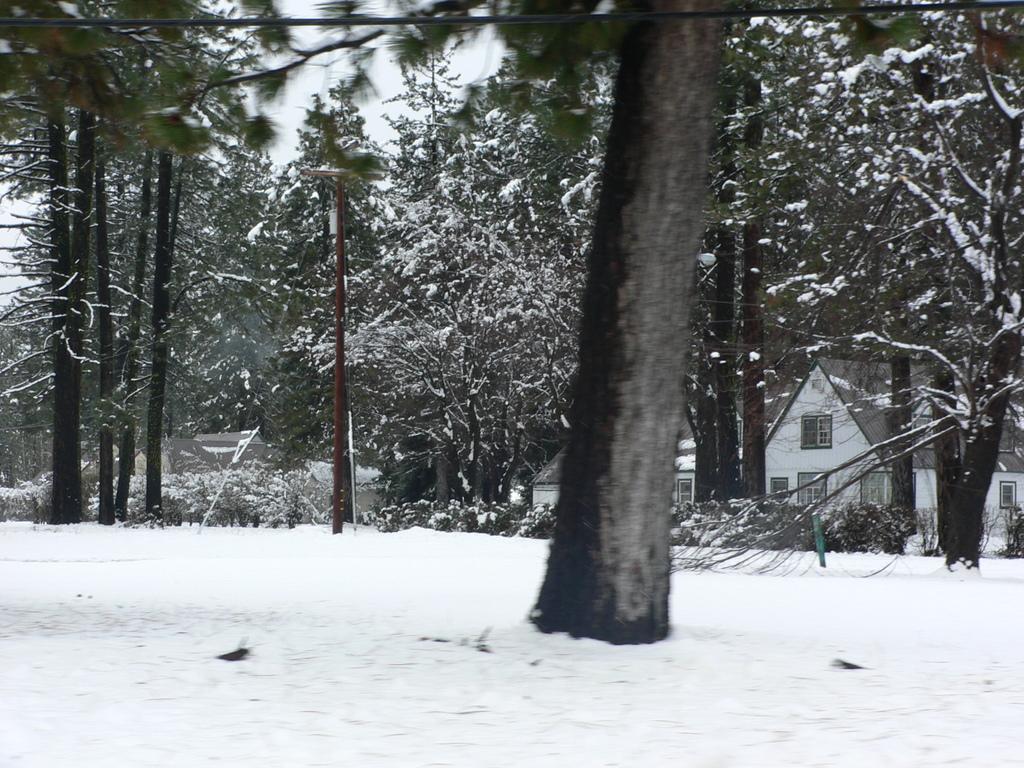Could you give a brief overview of what you see in this image? In this picture we can see snow and trees and in the background we can see houses, electric pole and a metal pole. 